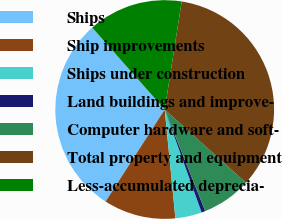<chart> <loc_0><loc_0><loc_500><loc_500><pie_chart><fcel>Ships<fcel>Ship improvements<fcel>Ships under construction<fcel>Land buildings and improve-<fcel>Computer hardware and soft-<fcel>Total property and equipment<fcel>Less-accumulated deprecia-<nl><fcel>29.39%<fcel>10.65%<fcel>3.92%<fcel>0.56%<fcel>7.28%<fcel>34.2%<fcel>14.01%<nl></chart> 